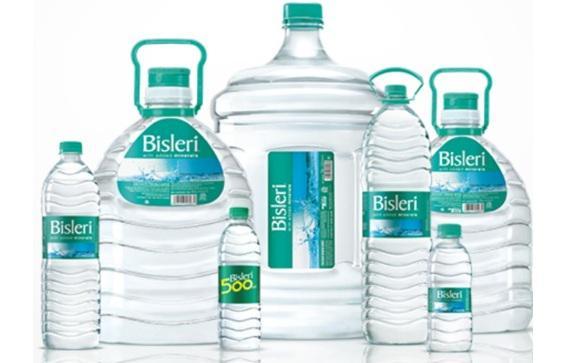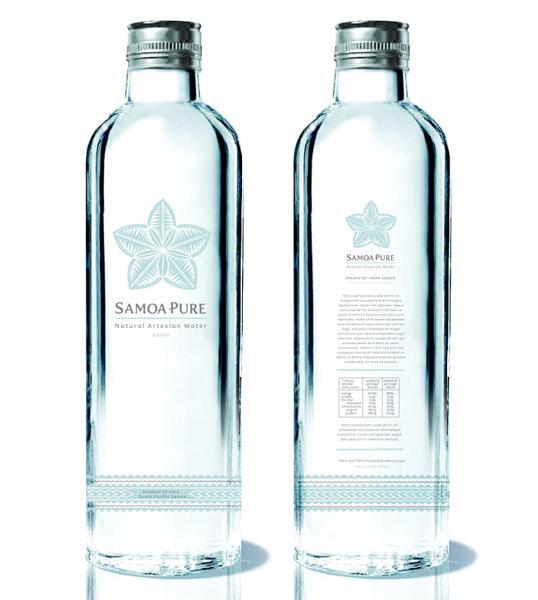The first image is the image on the left, the second image is the image on the right. For the images displayed, is the sentence "At least one image includes a yellow tennis ball next to a water bottle." factually correct? Answer yes or no. No. The first image is the image on the left, the second image is the image on the right. For the images displayed, is the sentence "There is at least one tennis ball near a water bottle." factually correct? Answer yes or no. No. 